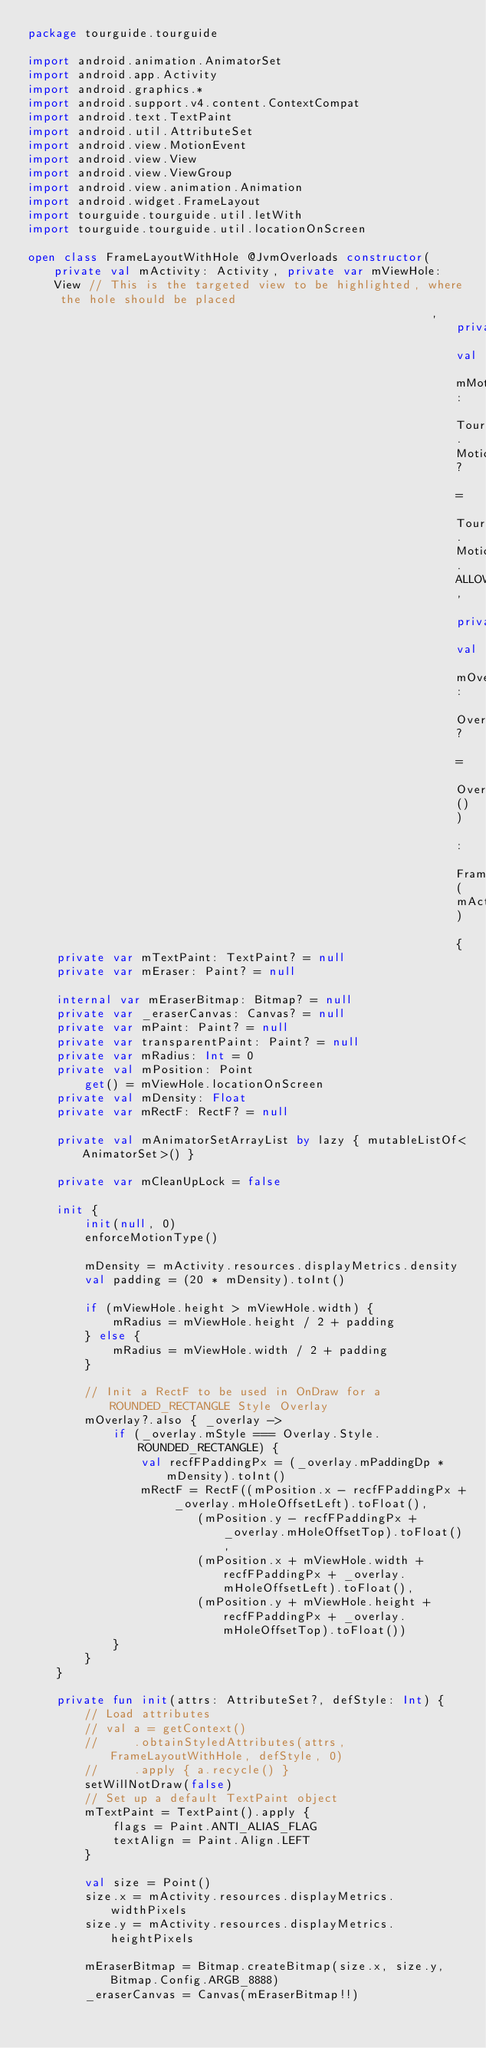Convert code to text. <code><loc_0><loc_0><loc_500><loc_500><_Kotlin_>package tourguide.tourguide

import android.animation.AnimatorSet
import android.app.Activity
import android.graphics.*
import android.support.v4.content.ContextCompat
import android.text.TextPaint
import android.util.AttributeSet
import android.view.MotionEvent
import android.view.View
import android.view.ViewGroup
import android.view.animation.Animation
import android.widget.FrameLayout
import tourguide.tourguide.util.letWith
import tourguide.tourguide.util.locationOnScreen

open class FrameLayoutWithHole @JvmOverloads constructor(private val mActivity: Activity, private var mViewHole: View // This is the targeted view to be highlighted, where the hole should be placed
                                                         , private val mMotionType: TourGuide.MotionType? = TourGuide.MotionType.ALLOW_ALL, private val mOverlay: Overlay? = Overlay()) : FrameLayout(mActivity) {
    private var mTextPaint: TextPaint? = null
    private var mEraser: Paint? = null

    internal var mEraserBitmap: Bitmap? = null
    private var _eraserCanvas: Canvas? = null
    private var mPaint: Paint? = null
    private var transparentPaint: Paint? = null
    private var mRadius: Int = 0
    private val mPosition: Point
        get() = mViewHole.locationOnScreen
    private val mDensity: Float
    private var mRectF: RectF? = null

    private val mAnimatorSetArrayList by lazy { mutableListOf<AnimatorSet>() }

    private var mCleanUpLock = false

    init {
        init(null, 0)
        enforceMotionType()

        mDensity = mActivity.resources.displayMetrics.density
        val padding = (20 * mDensity).toInt()

        if (mViewHole.height > mViewHole.width) {
            mRadius = mViewHole.height / 2 + padding
        } else {
            mRadius = mViewHole.width / 2 + padding
        }

        // Init a RectF to be used in OnDraw for a ROUNDED_RECTANGLE Style Overlay
        mOverlay?.also { _overlay ->
            if (_overlay.mStyle === Overlay.Style.ROUNDED_RECTANGLE) {
                val recfFPaddingPx = (_overlay.mPaddingDp * mDensity).toInt()
                mRectF = RectF((mPosition.x - recfFPaddingPx + _overlay.mHoleOffsetLeft).toFloat(),
                        (mPosition.y - recfFPaddingPx + _overlay.mHoleOffsetTop).toFloat(),
                        (mPosition.x + mViewHole.width + recfFPaddingPx + _overlay.mHoleOffsetLeft).toFloat(),
                        (mPosition.y + mViewHole.height + recfFPaddingPx + _overlay.mHoleOffsetTop).toFloat())
            }
        }
    }

    private fun init(attrs: AttributeSet?, defStyle: Int) {
        // Load attributes
        // val a = getContext()
        //     .obtainStyledAttributes(attrs, FrameLayoutWithHole, defStyle, 0)
        //     .apply { a.recycle() }
        setWillNotDraw(false)
        // Set up a default TextPaint object
        mTextPaint = TextPaint().apply {
            flags = Paint.ANTI_ALIAS_FLAG
            textAlign = Paint.Align.LEFT
        }

        val size = Point()
        size.x = mActivity.resources.displayMetrics.widthPixels
        size.y = mActivity.resources.displayMetrics.heightPixels

        mEraserBitmap = Bitmap.createBitmap(size.x, size.y, Bitmap.Config.ARGB_8888)
        _eraserCanvas = Canvas(mEraserBitmap!!)
</code> 